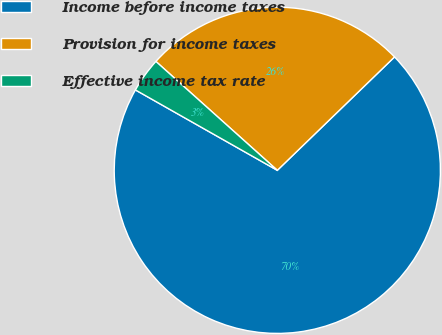Convert chart to OTSL. <chart><loc_0><loc_0><loc_500><loc_500><pie_chart><fcel>Income before income taxes<fcel>Provision for income taxes<fcel>Effective income tax rate<nl><fcel>70.44%<fcel>26.13%<fcel>3.43%<nl></chart> 